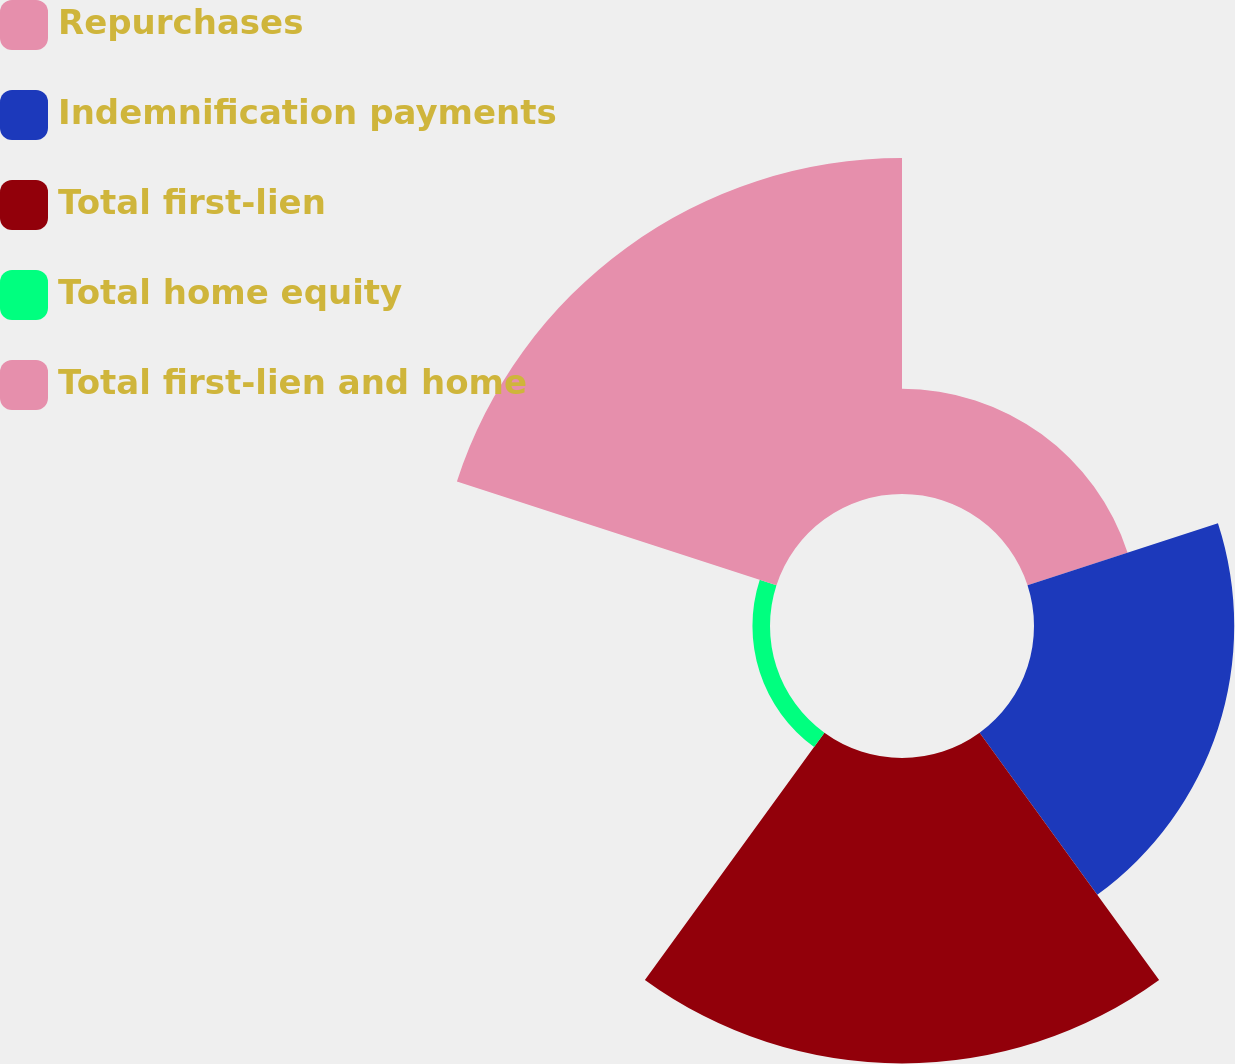<chart> <loc_0><loc_0><loc_500><loc_500><pie_chart><fcel>Repurchases<fcel>Indemnification payments<fcel>Total first-lien<fcel>Total home equity<fcel>Total first-lien and home<nl><fcel>10.91%<fcel>20.76%<fcel>31.67%<fcel>1.82%<fcel>34.84%<nl></chart> 